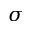<formula> <loc_0><loc_0><loc_500><loc_500>\sigma</formula> 